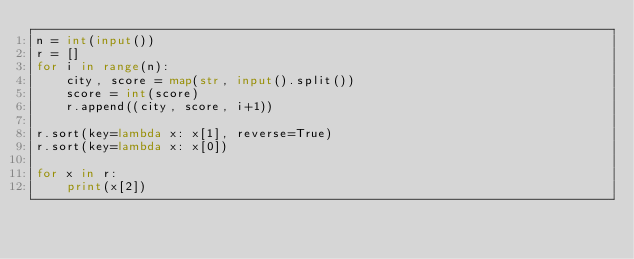Convert code to text. <code><loc_0><loc_0><loc_500><loc_500><_Python_>n = int(input())
r = []
for i in range(n):
    city, score = map(str, input().split())
    score = int(score)
    r.append((city, score, i+1))

r.sort(key=lambda x: x[1], reverse=True)
r.sort(key=lambda x: x[0])

for x in r:
    print(x[2])
</code> 